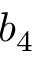<formula> <loc_0><loc_0><loc_500><loc_500>b _ { 4 }</formula> 